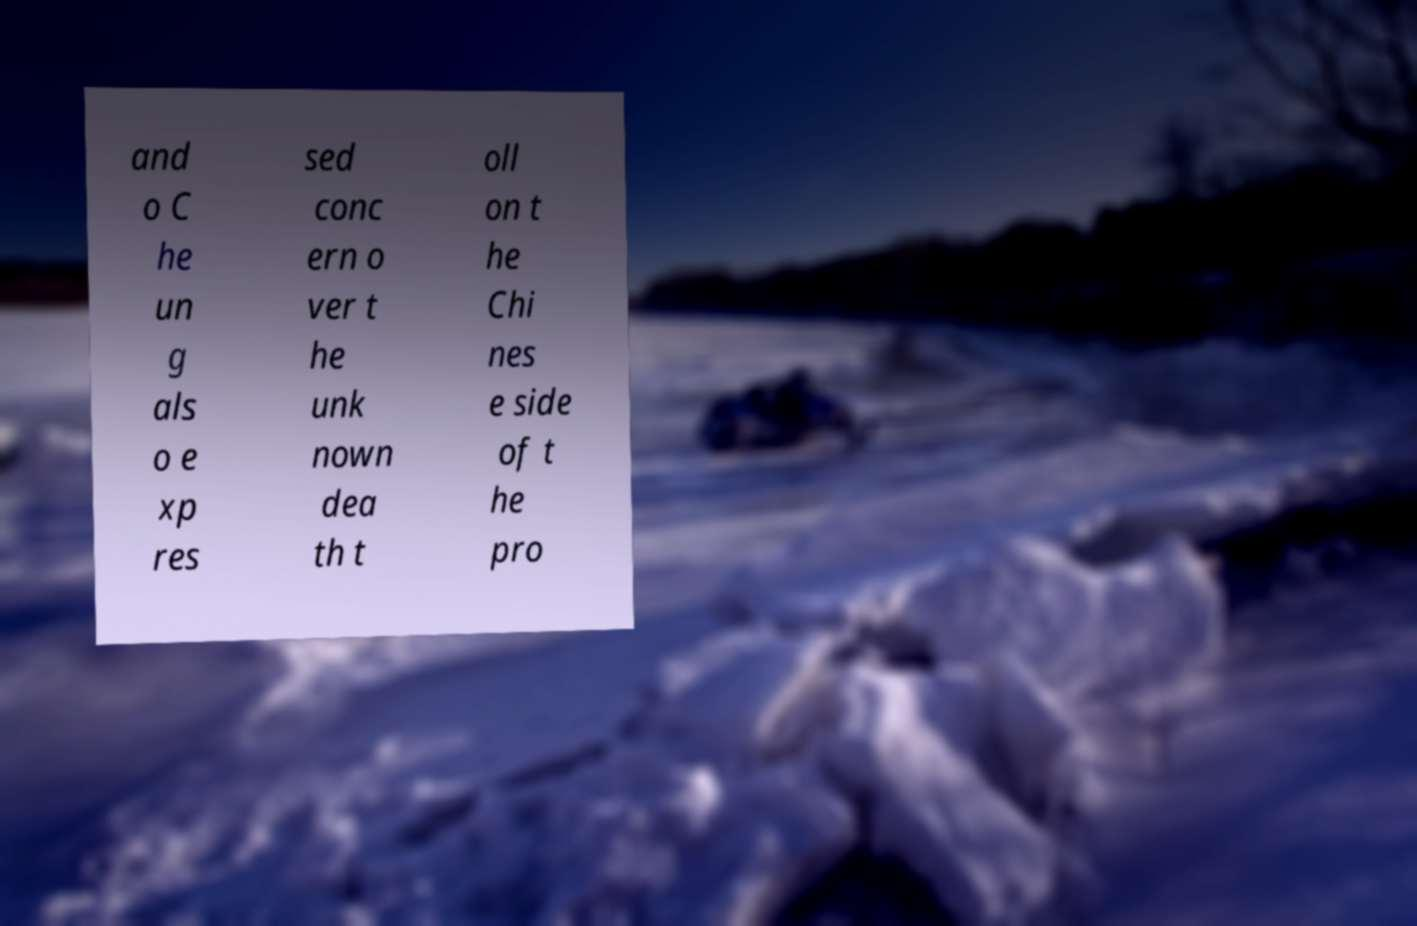There's text embedded in this image that I need extracted. Can you transcribe it verbatim? and o C he un g als o e xp res sed conc ern o ver t he unk nown dea th t oll on t he Chi nes e side of t he pro 